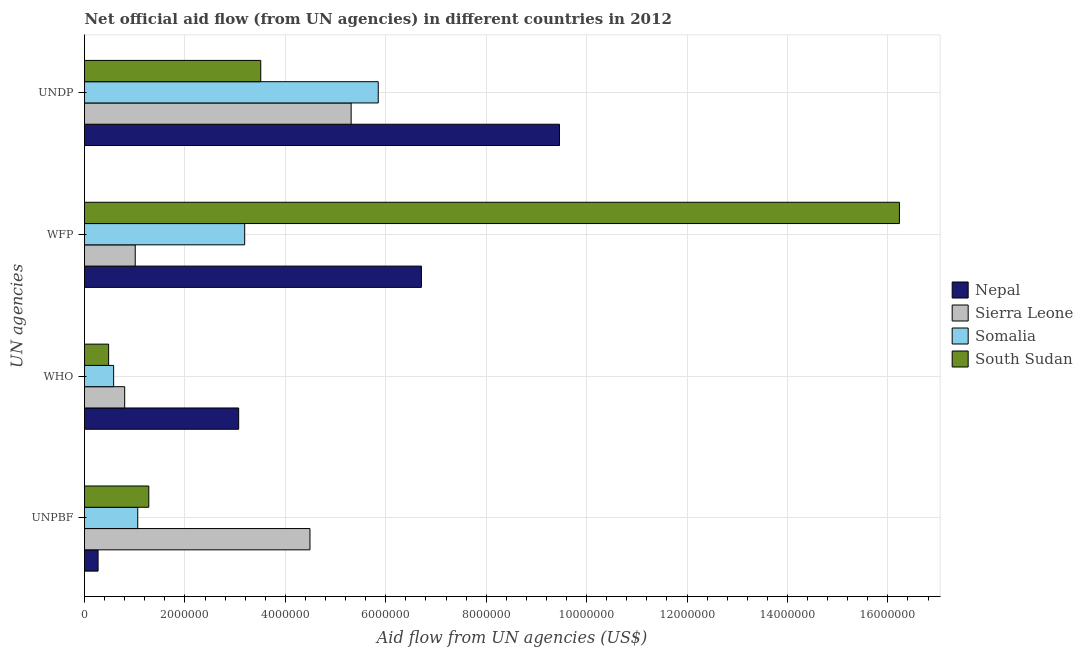How many different coloured bars are there?
Offer a terse response. 4. How many groups of bars are there?
Give a very brief answer. 4. Are the number of bars on each tick of the Y-axis equal?
Provide a succinct answer. Yes. How many bars are there on the 2nd tick from the bottom?
Offer a very short reply. 4. What is the label of the 2nd group of bars from the top?
Offer a very short reply. WFP. What is the amount of aid given by unpbf in South Sudan?
Offer a very short reply. 1.28e+06. Across all countries, what is the maximum amount of aid given by wfp?
Keep it short and to the point. 1.62e+07. Across all countries, what is the minimum amount of aid given by unpbf?
Ensure brevity in your answer.  2.70e+05. In which country was the amount of aid given by who maximum?
Your answer should be very brief. Nepal. In which country was the amount of aid given by who minimum?
Provide a succinct answer. South Sudan. What is the total amount of aid given by wfp in the graph?
Your answer should be very brief. 2.71e+07. What is the difference between the amount of aid given by wfp in South Sudan and that in Sierra Leone?
Keep it short and to the point. 1.52e+07. What is the difference between the amount of aid given by who in South Sudan and the amount of aid given by wfp in Nepal?
Your response must be concise. -6.23e+06. What is the average amount of aid given by wfp per country?
Provide a succinct answer. 6.78e+06. What is the difference between the amount of aid given by unpbf and amount of aid given by undp in Sierra Leone?
Your answer should be compact. -8.20e+05. What is the ratio of the amount of aid given by unpbf in Nepal to that in Sierra Leone?
Ensure brevity in your answer.  0.06. What is the difference between the highest and the second highest amount of aid given by wfp?
Ensure brevity in your answer.  9.52e+06. What is the difference between the highest and the lowest amount of aid given by unpbf?
Your answer should be compact. 4.22e+06. Is it the case that in every country, the sum of the amount of aid given by who and amount of aid given by wfp is greater than the sum of amount of aid given by unpbf and amount of aid given by undp?
Offer a terse response. No. What does the 2nd bar from the top in UNPBF represents?
Make the answer very short. Somalia. What does the 1st bar from the bottom in UNDP represents?
Offer a very short reply. Nepal. Is it the case that in every country, the sum of the amount of aid given by unpbf and amount of aid given by who is greater than the amount of aid given by wfp?
Your answer should be compact. No. How many bars are there?
Keep it short and to the point. 16. Are all the bars in the graph horizontal?
Provide a succinct answer. Yes. How many countries are there in the graph?
Your answer should be very brief. 4. What is the difference between two consecutive major ticks on the X-axis?
Provide a short and direct response. 2.00e+06. Does the graph contain grids?
Your response must be concise. Yes. Where does the legend appear in the graph?
Your response must be concise. Center right. How many legend labels are there?
Ensure brevity in your answer.  4. How are the legend labels stacked?
Your answer should be very brief. Vertical. What is the title of the graph?
Provide a short and direct response. Net official aid flow (from UN agencies) in different countries in 2012. Does "Arab World" appear as one of the legend labels in the graph?
Your answer should be compact. No. What is the label or title of the X-axis?
Ensure brevity in your answer.  Aid flow from UN agencies (US$). What is the label or title of the Y-axis?
Ensure brevity in your answer.  UN agencies. What is the Aid flow from UN agencies (US$) in Nepal in UNPBF?
Provide a succinct answer. 2.70e+05. What is the Aid flow from UN agencies (US$) in Sierra Leone in UNPBF?
Offer a terse response. 4.49e+06. What is the Aid flow from UN agencies (US$) in Somalia in UNPBF?
Give a very brief answer. 1.06e+06. What is the Aid flow from UN agencies (US$) in South Sudan in UNPBF?
Give a very brief answer. 1.28e+06. What is the Aid flow from UN agencies (US$) of Nepal in WHO?
Your response must be concise. 3.07e+06. What is the Aid flow from UN agencies (US$) in Sierra Leone in WHO?
Ensure brevity in your answer.  8.00e+05. What is the Aid flow from UN agencies (US$) of Somalia in WHO?
Offer a terse response. 5.80e+05. What is the Aid flow from UN agencies (US$) in Nepal in WFP?
Ensure brevity in your answer.  6.71e+06. What is the Aid flow from UN agencies (US$) in Sierra Leone in WFP?
Offer a terse response. 1.01e+06. What is the Aid flow from UN agencies (US$) of Somalia in WFP?
Your answer should be compact. 3.19e+06. What is the Aid flow from UN agencies (US$) in South Sudan in WFP?
Offer a very short reply. 1.62e+07. What is the Aid flow from UN agencies (US$) of Nepal in UNDP?
Your answer should be compact. 9.46e+06. What is the Aid flow from UN agencies (US$) in Sierra Leone in UNDP?
Give a very brief answer. 5.31e+06. What is the Aid flow from UN agencies (US$) of Somalia in UNDP?
Your answer should be very brief. 5.85e+06. What is the Aid flow from UN agencies (US$) in South Sudan in UNDP?
Make the answer very short. 3.51e+06. Across all UN agencies, what is the maximum Aid flow from UN agencies (US$) in Nepal?
Provide a short and direct response. 9.46e+06. Across all UN agencies, what is the maximum Aid flow from UN agencies (US$) in Sierra Leone?
Provide a succinct answer. 5.31e+06. Across all UN agencies, what is the maximum Aid flow from UN agencies (US$) in Somalia?
Offer a terse response. 5.85e+06. Across all UN agencies, what is the maximum Aid flow from UN agencies (US$) of South Sudan?
Ensure brevity in your answer.  1.62e+07. Across all UN agencies, what is the minimum Aid flow from UN agencies (US$) of Somalia?
Your response must be concise. 5.80e+05. What is the total Aid flow from UN agencies (US$) in Nepal in the graph?
Give a very brief answer. 1.95e+07. What is the total Aid flow from UN agencies (US$) of Sierra Leone in the graph?
Your answer should be compact. 1.16e+07. What is the total Aid flow from UN agencies (US$) of Somalia in the graph?
Your answer should be very brief. 1.07e+07. What is the total Aid flow from UN agencies (US$) in South Sudan in the graph?
Your answer should be compact. 2.15e+07. What is the difference between the Aid flow from UN agencies (US$) of Nepal in UNPBF and that in WHO?
Your answer should be very brief. -2.80e+06. What is the difference between the Aid flow from UN agencies (US$) of Sierra Leone in UNPBF and that in WHO?
Ensure brevity in your answer.  3.69e+06. What is the difference between the Aid flow from UN agencies (US$) in Somalia in UNPBF and that in WHO?
Make the answer very short. 4.80e+05. What is the difference between the Aid flow from UN agencies (US$) in Nepal in UNPBF and that in WFP?
Give a very brief answer. -6.44e+06. What is the difference between the Aid flow from UN agencies (US$) of Sierra Leone in UNPBF and that in WFP?
Give a very brief answer. 3.48e+06. What is the difference between the Aid flow from UN agencies (US$) of Somalia in UNPBF and that in WFP?
Make the answer very short. -2.13e+06. What is the difference between the Aid flow from UN agencies (US$) of South Sudan in UNPBF and that in WFP?
Your answer should be very brief. -1.50e+07. What is the difference between the Aid flow from UN agencies (US$) in Nepal in UNPBF and that in UNDP?
Ensure brevity in your answer.  -9.19e+06. What is the difference between the Aid flow from UN agencies (US$) of Sierra Leone in UNPBF and that in UNDP?
Your response must be concise. -8.20e+05. What is the difference between the Aid flow from UN agencies (US$) in Somalia in UNPBF and that in UNDP?
Offer a terse response. -4.79e+06. What is the difference between the Aid flow from UN agencies (US$) of South Sudan in UNPBF and that in UNDP?
Provide a short and direct response. -2.23e+06. What is the difference between the Aid flow from UN agencies (US$) of Nepal in WHO and that in WFP?
Provide a succinct answer. -3.64e+06. What is the difference between the Aid flow from UN agencies (US$) of Sierra Leone in WHO and that in WFP?
Your answer should be compact. -2.10e+05. What is the difference between the Aid flow from UN agencies (US$) of Somalia in WHO and that in WFP?
Offer a very short reply. -2.61e+06. What is the difference between the Aid flow from UN agencies (US$) of South Sudan in WHO and that in WFP?
Your response must be concise. -1.58e+07. What is the difference between the Aid flow from UN agencies (US$) of Nepal in WHO and that in UNDP?
Keep it short and to the point. -6.39e+06. What is the difference between the Aid flow from UN agencies (US$) in Sierra Leone in WHO and that in UNDP?
Provide a succinct answer. -4.51e+06. What is the difference between the Aid flow from UN agencies (US$) of Somalia in WHO and that in UNDP?
Your answer should be compact. -5.27e+06. What is the difference between the Aid flow from UN agencies (US$) in South Sudan in WHO and that in UNDP?
Your response must be concise. -3.03e+06. What is the difference between the Aid flow from UN agencies (US$) of Nepal in WFP and that in UNDP?
Offer a terse response. -2.75e+06. What is the difference between the Aid flow from UN agencies (US$) of Sierra Leone in WFP and that in UNDP?
Offer a very short reply. -4.30e+06. What is the difference between the Aid flow from UN agencies (US$) in Somalia in WFP and that in UNDP?
Your response must be concise. -2.66e+06. What is the difference between the Aid flow from UN agencies (US$) of South Sudan in WFP and that in UNDP?
Your answer should be compact. 1.27e+07. What is the difference between the Aid flow from UN agencies (US$) of Nepal in UNPBF and the Aid flow from UN agencies (US$) of Sierra Leone in WHO?
Offer a terse response. -5.30e+05. What is the difference between the Aid flow from UN agencies (US$) of Nepal in UNPBF and the Aid flow from UN agencies (US$) of Somalia in WHO?
Give a very brief answer. -3.10e+05. What is the difference between the Aid flow from UN agencies (US$) of Nepal in UNPBF and the Aid flow from UN agencies (US$) of South Sudan in WHO?
Offer a terse response. -2.10e+05. What is the difference between the Aid flow from UN agencies (US$) in Sierra Leone in UNPBF and the Aid flow from UN agencies (US$) in Somalia in WHO?
Provide a short and direct response. 3.91e+06. What is the difference between the Aid flow from UN agencies (US$) in Sierra Leone in UNPBF and the Aid flow from UN agencies (US$) in South Sudan in WHO?
Your answer should be very brief. 4.01e+06. What is the difference between the Aid flow from UN agencies (US$) of Somalia in UNPBF and the Aid flow from UN agencies (US$) of South Sudan in WHO?
Your answer should be compact. 5.80e+05. What is the difference between the Aid flow from UN agencies (US$) of Nepal in UNPBF and the Aid flow from UN agencies (US$) of Sierra Leone in WFP?
Offer a very short reply. -7.40e+05. What is the difference between the Aid flow from UN agencies (US$) of Nepal in UNPBF and the Aid flow from UN agencies (US$) of Somalia in WFP?
Offer a very short reply. -2.92e+06. What is the difference between the Aid flow from UN agencies (US$) of Nepal in UNPBF and the Aid flow from UN agencies (US$) of South Sudan in WFP?
Keep it short and to the point. -1.60e+07. What is the difference between the Aid flow from UN agencies (US$) of Sierra Leone in UNPBF and the Aid flow from UN agencies (US$) of Somalia in WFP?
Provide a short and direct response. 1.30e+06. What is the difference between the Aid flow from UN agencies (US$) in Sierra Leone in UNPBF and the Aid flow from UN agencies (US$) in South Sudan in WFP?
Your response must be concise. -1.17e+07. What is the difference between the Aid flow from UN agencies (US$) in Somalia in UNPBF and the Aid flow from UN agencies (US$) in South Sudan in WFP?
Ensure brevity in your answer.  -1.52e+07. What is the difference between the Aid flow from UN agencies (US$) of Nepal in UNPBF and the Aid flow from UN agencies (US$) of Sierra Leone in UNDP?
Offer a terse response. -5.04e+06. What is the difference between the Aid flow from UN agencies (US$) of Nepal in UNPBF and the Aid flow from UN agencies (US$) of Somalia in UNDP?
Your answer should be very brief. -5.58e+06. What is the difference between the Aid flow from UN agencies (US$) of Nepal in UNPBF and the Aid flow from UN agencies (US$) of South Sudan in UNDP?
Keep it short and to the point. -3.24e+06. What is the difference between the Aid flow from UN agencies (US$) of Sierra Leone in UNPBF and the Aid flow from UN agencies (US$) of Somalia in UNDP?
Offer a very short reply. -1.36e+06. What is the difference between the Aid flow from UN agencies (US$) of Sierra Leone in UNPBF and the Aid flow from UN agencies (US$) of South Sudan in UNDP?
Your answer should be very brief. 9.80e+05. What is the difference between the Aid flow from UN agencies (US$) in Somalia in UNPBF and the Aid flow from UN agencies (US$) in South Sudan in UNDP?
Make the answer very short. -2.45e+06. What is the difference between the Aid flow from UN agencies (US$) of Nepal in WHO and the Aid flow from UN agencies (US$) of Sierra Leone in WFP?
Your response must be concise. 2.06e+06. What is the difference between the Aid flow from UN agencies (US$) in Nepal in WHO and the Aid flow from UN agencies (US$) in Somalia in WFP?
Offer a terse response. -1.20e+05. What is the difference between the Aid flow from UN agencies (US$) of Nepal in WHO and the Aid flow from UN agencies (US$) of South Sudan in WFP?
Your answer should be very brief. -1.32e+07. What is the difference between the Aid flow from UN agencies (US$) of Sierra Leone in WHO and the Aid flow from UN agencies (US$) of Somalia in WFP?
Your response must be concise. -2.39e+06. What is the difference between the Aid flow from UN agencies (US$) of Sierra Leone in WHO and the Aid flow from UN agencies (US$) of South Sudan in WFP?
Ensure brevity in your answer.  -1.54e+07. What is the difference between the Aid flow from UN agencies (US$) of Somalia in WHO and the Aid flow from UN agencies (US$) of South Sudan in WFP?
Your answer should be very brief. -1.56e+07. What is the difference between the Aid flow from UN agencies (US$) in Nepal in WHO and the Aid flow from UN agencies (US$) in Sierra Leone in UNDP?
Offer a terse response. -2.24e+06. What is the difference between the Aid flow from UN agencies (US$) of Nepal in WHO and the Aid flow from UN agencies (US$) of Somalia in UNDP?
Ensure brevity in your answer.  -2.78e+06. What is the difference between the Aid flow from UN agencies (US$) of Nepal in WHO and the Aid flow from UN agencies (US$) of South Sudan in UNDP?
Provide a short and direct response. -4.40e+05. What is the difference between the Aid flow from UN agencies (US$) of Sierra Leone in WHO and the Aid flow from UN agencies (US$) of Somalia in UNDP?
Provide a short and direct response. -5.05e+06. What is the difference between the Aid flow from UN agencies (US$) in Sierra Leone in WHO and the Aid flow from UN agencies (US$) in South Sudan in UNDP?
Provide a succinct answer. -2.71e+06. What is the difference between the Aid flow from UN agencies (US$) of Somalia in WHO and the Aid flow from UN agencies (US$) of South Sudan in UNDP?
Provide a succinct answer. -2.93e+06. What is the difference between the Aid flow from UN agencies (US$) of Nepal in WFP and the Aid flow from UN agencies (US$) of Sierra Leone in UNDP?
Provide a succinct answer. 1.40e+06. What is the difference between the Aid flow from UN agencies (US$) in Nepal in WFP and the Aid flow from UN agencies (US$) in Somalia in UNDP?
Your response must be concise. 8.60e+05. What is the difference between the Aid flow from UN agencies (US$) of Nepal in WFP and the Aid flow from UN agencies (US$) of South Sudan in UNDP?
Your answer should be compact. 3.20e+06. What is the difference between the Aid flow from UN agencies (US$) in Sierra Leone in WFP and the Aid flow from UN agencies (US$) in Somalia in UNDP?
Your response must be concise. -4.84e+06. What is the difference between the Aid flow from UN agencies (US$) of Sierra Leone in WFP and the Aid flow from UN agencies (US$) of South Sudan in UNDP?
Make the answer very short. -2.50e+06. What is the difference between the Aid flow from UN agencies (US$) of Somalia in WFP and the Aid flow from UN agencies (US$) of South Sudan in UNDP?
Offer a very short reply. -3.20e+05. What is the average Aid flow from UN agencies (US$) in Nepal per UN agencies?
Provide a succinct answer. 4.88e+06. What is the average Aid flow from UN agencies (US$) of Sierra Leone per UN agencies?
Offer a very short reply. 2.90e+06. What is the average Aid flow from UN agencies (US$) of Somalia per UN agencies?
Your answer should be very brief. 2.67e+06. What is the average Aid flow from UN agencies (US$) of South Sudan per UN agencies?
Keep it short and to the point. 5.38e+06. What is the difference between the Aid flow from UN agencies (US$) of Nepal and Aid flow from UN agencies (US$) of Sierra Leone in UNPBF?
Offer a very short reply. -4.22e+06. What is the difference between the Aid flow from UN agencies (US$) in Nepal and Aid flow from UN agencies (US$) in Somalia in UNPBF?
Your answer should be very brief. -7.90e+05. What is the difference between the Aid flow from UN agencies (US$) in Nepal and Aid flow from UN agencies (US$) in South Sudan in UNPBF?
Ensure brevity in your answer.  -1.01e+06. What is the difference between the Aid flow from UN agencies (US$) in Sierra Leone and Aid flow from UN agencies (US$) in Somalia in UNPBF?
Your answer should be compact. 3.43e+06. What is the difference between the Aid flow from UN agencies (US$) of Sierra Leone and Aid flow from UN agencies (US$) of South Sudan in UNPBF?
Make the answer very short. 3.21e+06. What is the difference between the Aid flow from UN agencies (US$) in Nepal and Aid flow from UN agencies (US$) in Sierra Leone in WHO?
Provide a succinct answer. 2.27e+06. What is the difference between the Aid flow from UN agencies (US$) of Nepal and Aid flow from UN agencies (US$) of Somalia in WHO?
Make the answer very short. 2.49e+06. What is the difference between the Aid flow from UN agencies (US$) of Nepal and Aid flow from UN agencies (US$) of South Sudan in WHO?
Your answer should be very brief. 2.59e+06. What is the difference between the Aid flow from UN agencies (US$) in Sierra Leone and Aid flow from UN agencies (US$) in South Sudan in WHO?
Ensure brevity in your answer.  3.20e+05. What is the difference between the Aid flow from UN agencies (US$) of Nepal and Aid flow from UN agencies (US$) of Sierra Leone in WFP?
Your answer should be compact. 5.70e+06. What is the difference between the Aid flow from UN agencies (US$) in Nepal and Aid flow from UN agencies (US$) in Somalia in WFP?
Provide a short and direct response. 3.52e+06. What is the difference between the Aid flow from UN agencies (US$) in Nepal and Aid flow from UN agencies (US$) in South Sudan in WFP?
Offer a very short reply. -9.52e+06. What is the difference between the Aid flow from UN agencies (US$) of Sierra Leone and Aid flow from UN agencies (US$) of Somalia in WFP?
Your answer should be compact. -2.18e+06. What is the difference between the Aid flow from UN agencies (US$) in Sierra Leone and Aid flow from UN agencies (US$) in South Sudan in WFP?
Ensure brevity in your answer.  -1.52e+07. What is the difference between the Aid flow from UN agencies (US$) of Somalia and Aid flow from UN agencies (US$) of South Sudan in WFP?
Ensure brevity in your answer.  -1.30e+07. What is the difference between the Aid flow from UN agencies (US$) of Nepal and Aid flow from UN agencies (US$) of Sierra Leone in UNDP?
Your response must be concise. 4.15e+06. What is the difference between the Aid flow from UN agencies (US$) in Nepal and Aid flow from UN agencies (US$) in Somalia in UNDP?
Provide a succinct answer. 3.61e+06. What is the difference between the Aid flow from UN agencies (US$) of Nepal and Aid flow from UN agencies (US$) of South Sudan in UNDP?
Ensure brevity in your answer.  5.95e+06. What is the difference between the Aid flow from UN agencies (US$) of Sierra Leone and Aid flow from UN agencies (US$) of Somalia in UNDP?
Keep it short and to the point. -5.40e+05. What is the difference between the Aid flow from UN agencies (US$) in Sierra Leone and Aid flow from UN agencies (US$) in South Sudan in UNDP?
Ensure brevity in your answer.  1.80e+06. What is the difference between the Aid flow from UN agencies (US$) in Somalia and Aid flow from UN agencies (US$) in South Sudan in UNDP?
Offer a terse response. 2.34e+06. What is the ratio of the Aid flow from UN agencies (US$) in Nepal in UNPBF to that in WHO?
Provide a short and direct response. 0.09. What is the ratio of the Aid flow from UN agencies (US$) of Sierra Leone in UNPBF to that in WHO?
Ensure brevity in your answer.  5.61. What is the ratio of the Aid flow from UN agencies (US$) in Somalia in UNPBF to that in WHO?
Your answer should be compact. 1.83. What is the ratio of the Aid flow from UN agencies (US$) in South Sudan in UNPBF to that in WHO?
Offer a terse response. 2.67. What is the ratio of the Aid flow from UN agencies (US$) in Nepal in UNPBF to that in WFP?
Give a very brief answer. 0.04. What is the ratio of the Aid flow from UN agencies (US$) of Sierra Leone in UNPBF to that in WFP?
Your response must be concise. 4.45. What is the ratio of the Aid flow from UN agencies (US$) of Somalia in UNPBF to that in WFP?
Keep it short and to the point. 0.33. What is the ratio of the Aid flow from UN agencies (US$) of South Sudan in UNPBF to that in WFP?
Give a very brief answer. 0.08. What is the ratio of the Aid flow from UN agencies (US$) of Nepal in UNPBF to that in UNDP?
Offer a terse response. 0.03. What is the ratio of the Aid flow from UN agencies (US$) in Sierra Leone in UNPBF to that in UNDP?
Make the answer very short. 0.85. What is the ratio of the Aid flow from UN agencies (US$) of Somalia in UNPBF to that in UNDP?
Offer a terse response. 0.18. What is the ratio of the Aid flow from UN agencies (US$) of South Sudan in UNPBF to that in UNDP?
Your answer should be very brief. 0.36. What is the ratio of the Aid flow from UN agencies (US$) of Nepal in WHO to that in WFP?
Offer a very short reply. 0.46. What is the ratio of the Aid flow from UN agencies (US$) in Sierra Leone in WHO to that in WFP?
Make the answer very short. 0.79. What is the ratio of the Aid flow from UN agencies (US$) in Somalia in WHO to that in WFP?
Ensure brevity in your answer.  0.18. What is the ratio of the Aid flow from UN agencies (US$) of South Sudan in WHO to that in WFP?
Make the answer very short. 0.03. What is the ratio of the Aid flow from UN agencies (US$) in Nepal in WHO to that in UNDP?
Provide a short and direct response. 0.32. What is the ratio of the Aid flow from UN agencies (US$) of Sierra Leone in WHO to that in UNDP?
Make the answer very short. 0.15. What is the ratio of the Aid flow from UN agencies (US$) in Somalia in WHO to that in UNDP?
Keep it short and to the point. 0.1. What is the ratio of the Aid flow from UN agencies (US$) of South Sudan in WHO to that in UNDP?
Offer a terse response. 0.14. What is the ratio of the Aid flow from UN agencies (US$) of Nepal in WFP to that in UNDP?
Ensure brevity in your answer.  0.71. What is the ratio of the Aid flow from UN agencies (US$) of Sierra Leone in WFP to that in UNDP?
Your answer should be compact. 0.19. What is the ratio of the Aid flow from UN agencies (US$) of Somalia in WFP to that in UNDP?
Keep it short and to the point. 0.55. What is the ratio of the Aid flow from UN agencies (US$) in South Sudan in WFP to that in UNDP?
Make the answer very short. 4.62. What is the difference between the highest and the second highest Aid flow from UN agencies (US$) of Nepal?
Provide a short and direct response. 2.75e+06. What is the difference between the highest and the second highest Aid flow from UN agencies (US$) of Sierra Leone?
Provide a succinct answer. 8.20e+05. What is the difference between the highest and the second highest Aid flow from UN agencies (US$) of Somalia?
Give a very brief answer. 2.66e+06. What is the difference between the highest and the second highest Aid flow from UN agencies (US$) in South Sudan?
Ensure brevity in your answer.  1.27e+07. What is the difference between the highest and the lowest Aid flow from UN agencies (US$) in Nepal?
Make the answer very short. 9.19e+06. What is the difference between the highest and the lowest Aid flow from UN agencies (US$) in Sierra Leone?
Provide a short and direct response. 4.51e+06. What is the difference between the highest and the lowest Aid flow from UN agencies (US$) of Somalia?
Your answer should be very brief. 5.27e+06. What is the difference between the highest and the lowest Aid flow from UN agencies (US$) of South Sudan?
Your answer should be compact. 1.58e+07. 